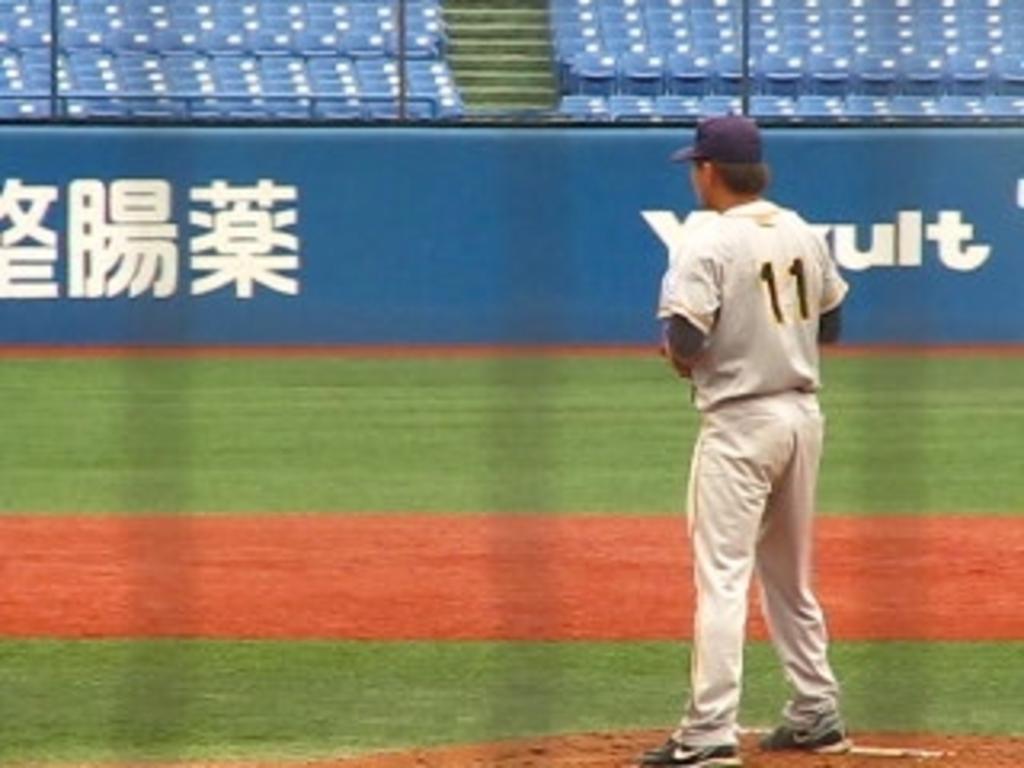What number is this player?
Keep it short and to the point. 11. Is the pitcher wearing number 45?
Give a very brief answer. No. 